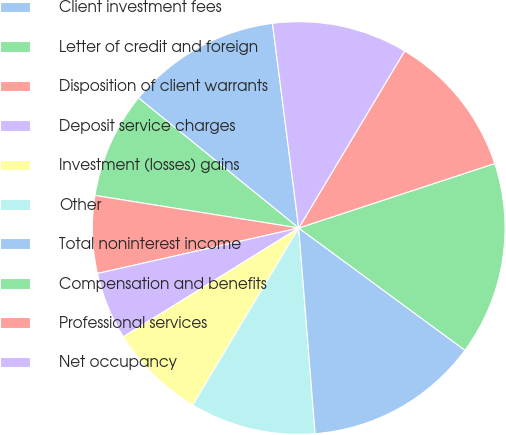<chart> <loc_0><loc_0><loc_500><loc_500><pie_chart><fcel>Client investment fees<fcel>Letter of credit and foreign<fcel>Disposition of client warrants<fcel>Deposit service charges<fcel>Investment (losses) gains<fcel>Other<fcel>Total noninterest income<fcel>Compensation and benefits<fcel>Professional services<fcel>Net occupancy<nl><fcel>12.12%<fcel>8.33%<fcel>6.06%<fcel>5.3%<fcel>7.58%<fcel>9.85%<fcel>13.64%<fcel>15.15%<fcel>11.36%<fcel>10.61%<nl></chart> 